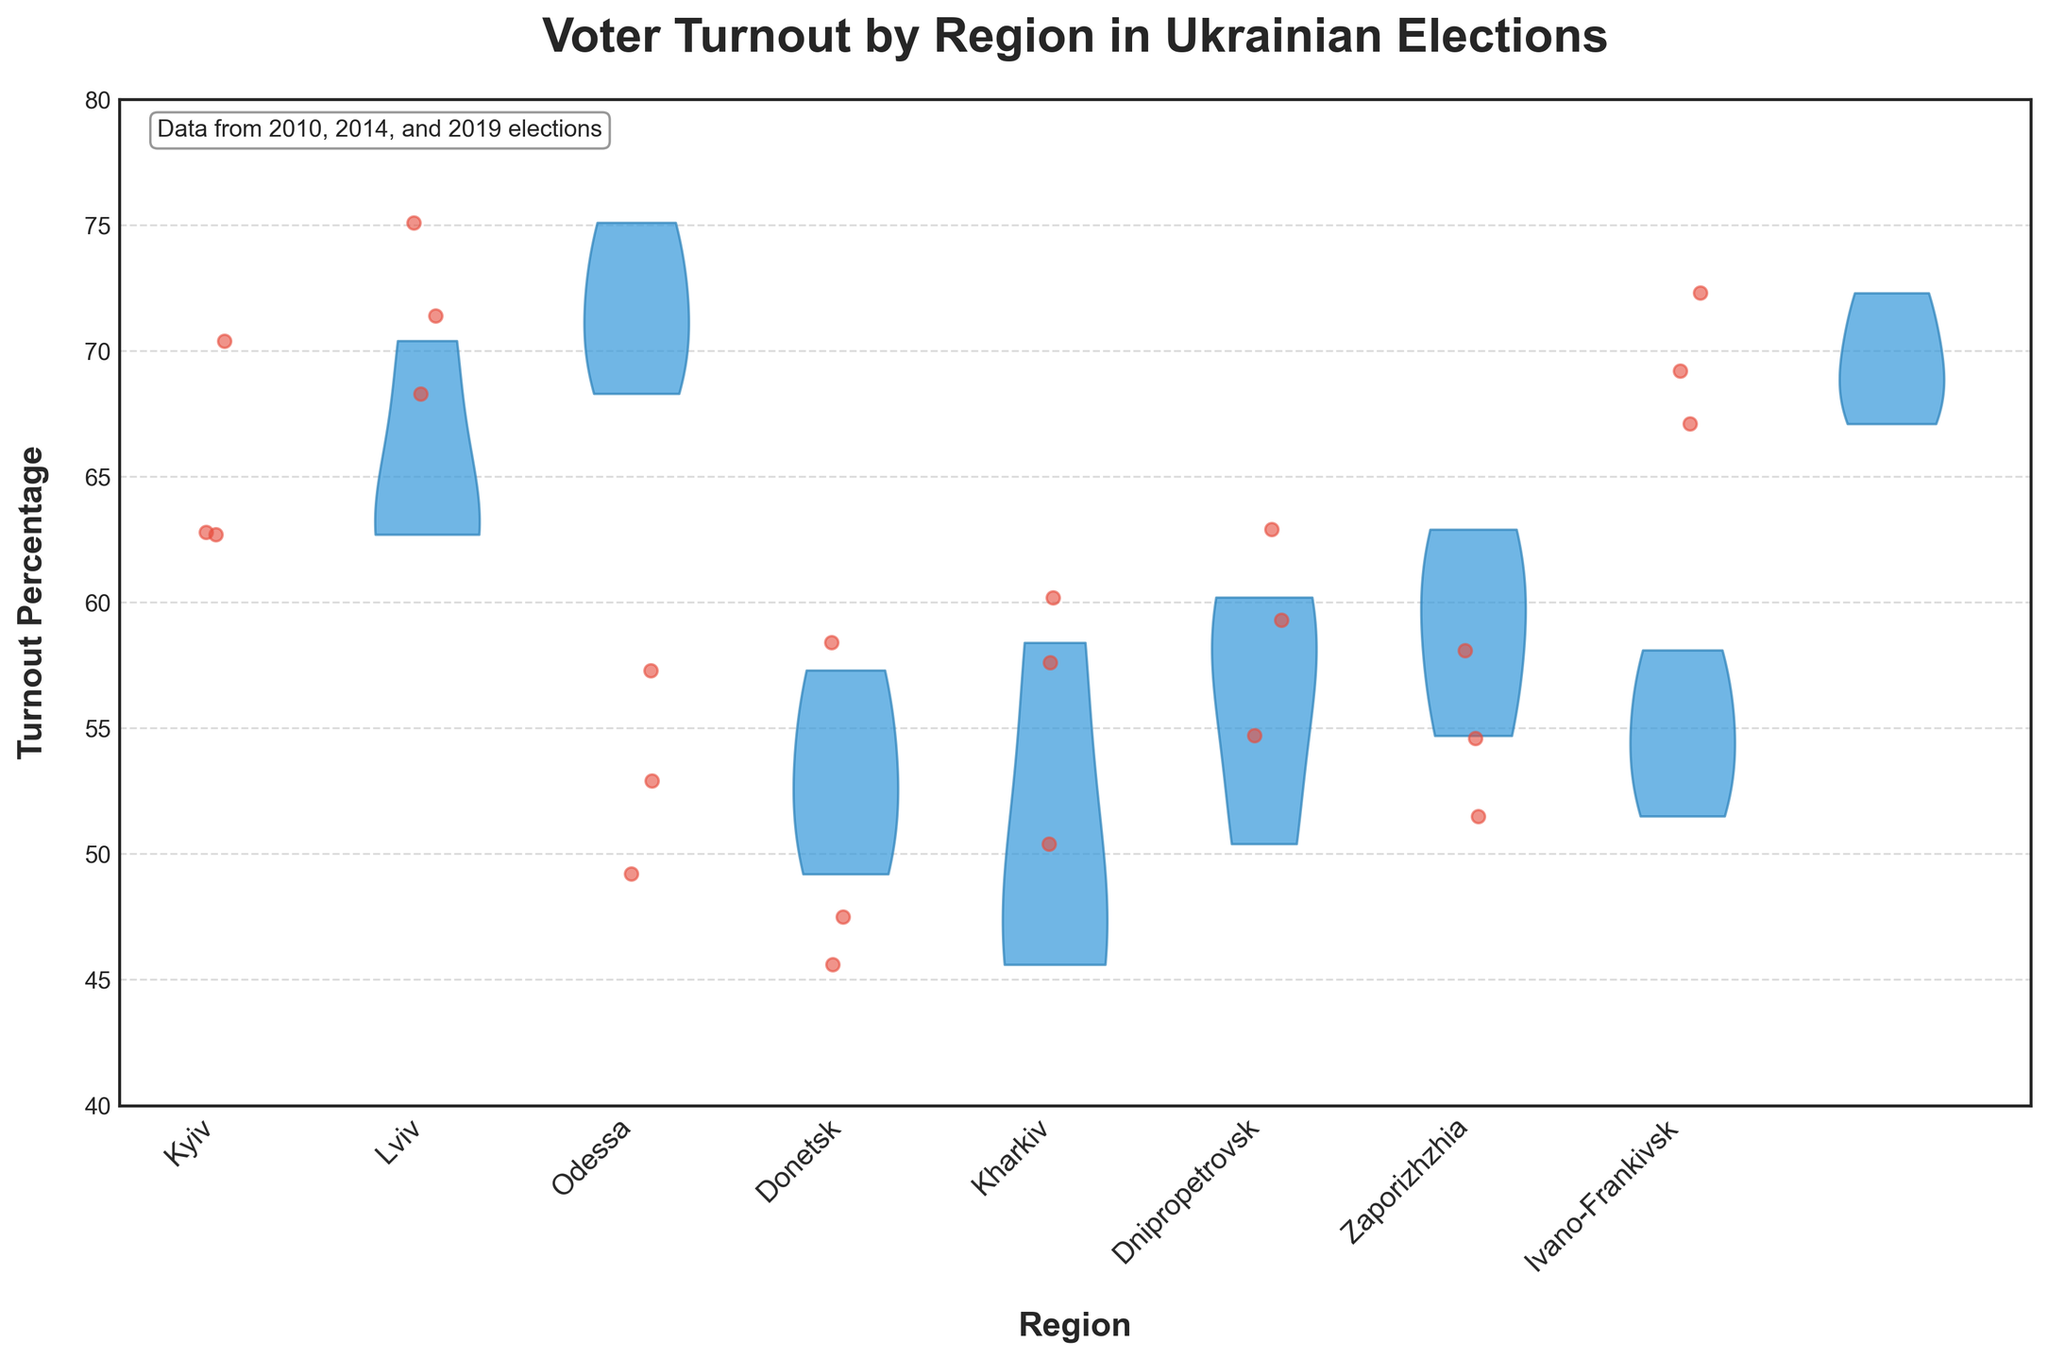Which region has the highest average voter turnout across the years? To find the region with the highest average voter turnout, we need to look at the voter turnout percentages for each region and calculate the average for each. Comparing these averages, Lviv shows consistently higher turnout percentages.
Answer: Lviv Which year had the lowest voter turnout in Donetsk? To find this, we check the voter turnout percentages in Donetsk for the years 2010, 2014, and 2019. The percentages are 58.4 in 2010, 47.5 in 2014, and 45.6 in 2019. The lowest is in 2019.
Answer: 2019 How does the voter turnout in Kyiv compare between 2010 and 2019? We compare the turnout percentages: 62.8% in 2010 and 62.7% in 2019. The turnout slightly decreased by 0.1 percentage points.
Answer: Slightly decreased Which region shows the most significant decrease in voter turnout from 2010 to 2019? To determine the region with the most significant decrease, calculate the difference in turnout between 2010 and 2019 for each region. For Donetsk, it decreased from 58.4 to 45.6, which is a drop of 12.8 percentage points, the most significant decrease.
Answer: Donetsk Which two regions have the most similar patterns in voter turnout across the years? By comparing the shapes and distribution of the violin plots and jittered points, Kyiv and Dnipropetrovsk show similar patterns in the distribution and trends over the years.
Answer: Kyiv and Dnipropetrovsk What is the turnout range (difference between maximum and minimum values) in Lviv? Calculating the range involves finding the highest and lowest turnout values in Lviv, which are 75.1 in 2014 and 68.3 in 2019, yielding a range of 75.1 - 68.3 = 6.8%.
Answer: 6.8% Which region has the most consistent voter turnout, with the smallest variability? From the violin plot shapes and the distribution of jittered points, Ivano-Frankivsk appears to have the smallest variability, indicating consistent voter turnout.
Answer: Ivano-Frankivsk 